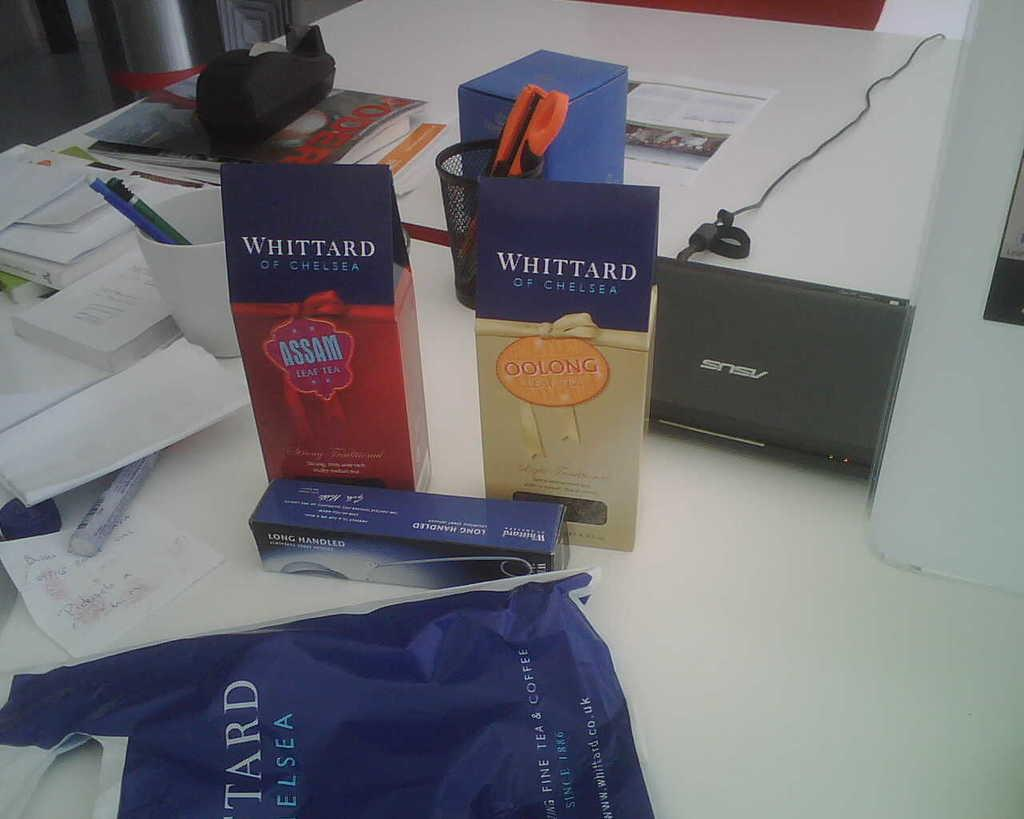<image>
Give a short and clear explanation of the subsequent image. Two Whittard of Chelsea packages are on a messy table. 